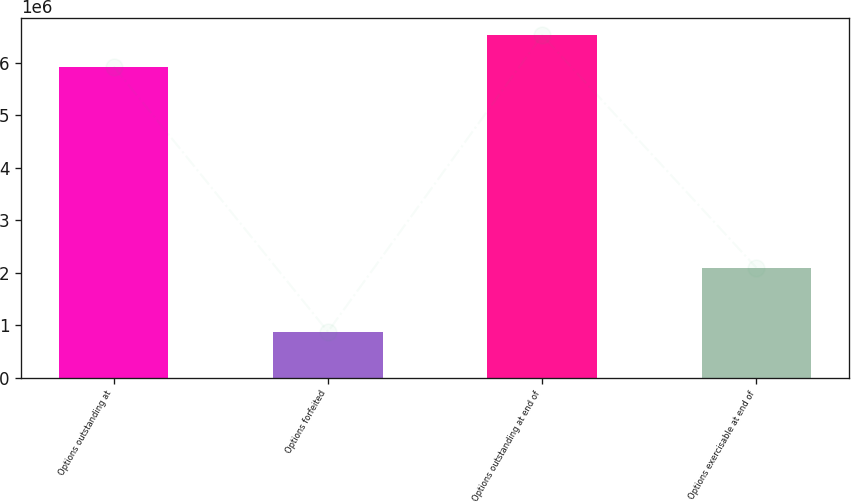<chart> <loc_0><loc_0><loc_500><loc_500><bar_chart><fcel>Options outstanding at<fcel>Options forfeited<fcel>Options outstanding at end of<fcel>Options exercisable at end of<nl><fcel>5.93206e+06<fcel>875000<fcel>6.52706e+06<fcel>2.09462e+06<nl></chart> 